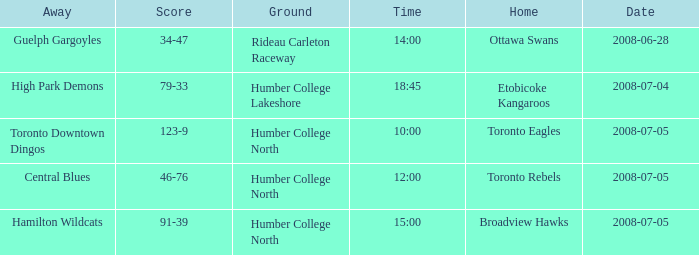What is the Away with a Time that is 14:00? Guelph Gargoyles. 